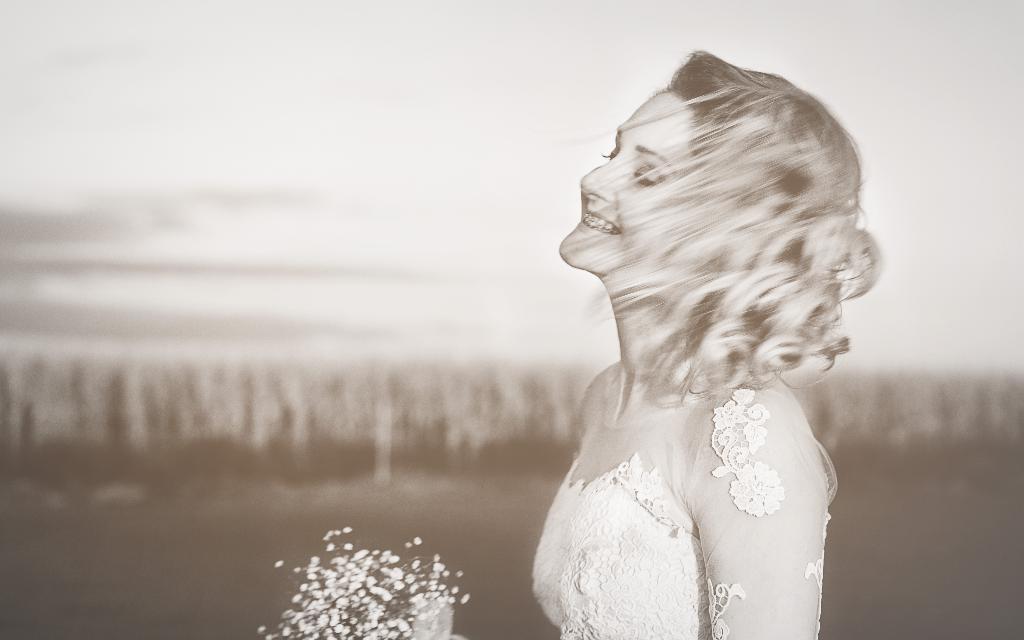In one or two sentences, can you explain what this image depicts? This is a black and white image. On the right side of the image a lady is smiling and holding a bouquet. In the background the image is blur. 